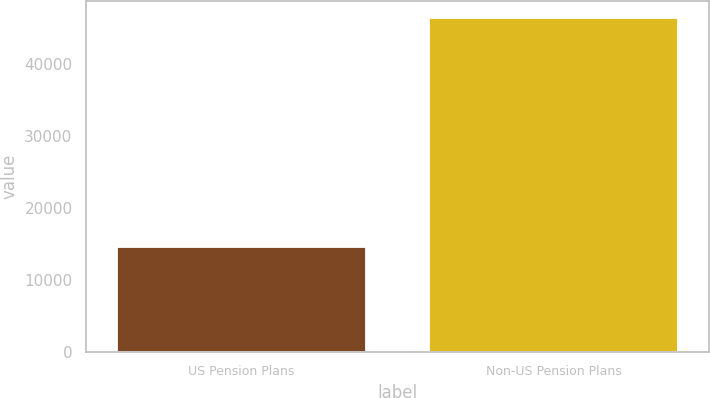Convert chart to OTSL. <chart><loc_0><loc_0><loc_500><loc_500><bar_chart><fcel>US Pension Plans<fcel>Non-US Pension Plans<nl><fcel>14603<fcel>46475<nl></chart> 